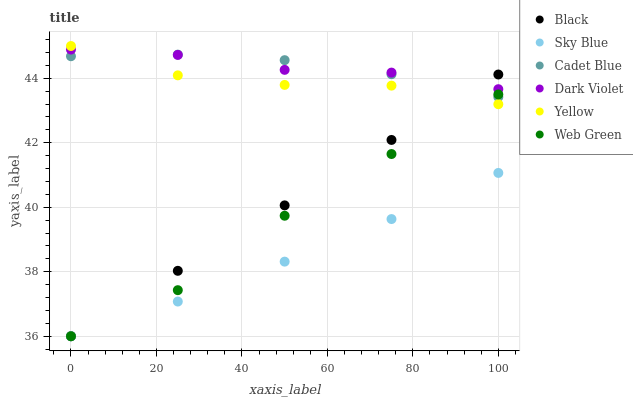Does Sky Blue have the minimum area under the curve?
Answer yes or no. Yes. Does Cadet Blue have the maximum area under the curve?
Answer yes or no. Yes. Does Dark Violet have the minimum area under the curve?
Answer yes or no. No. Does Dark Violet have the maximum area under the curve?
Answer yes or no. No. Is Black the smoothest?
Answer yes or no. Yes. Is Yellow the roughest?
Answer yes or no. Yes. Is Dark Violet the smoothest?
Answer yes or no. No. Is Dark Violet the roughest?
Answer yes or no. No. Does Web Green have the lowest value?
Answer yes or no. Yes. Does Dark Violet have the lowest value?
Answer yes or no. No. Does Yellow have the highest value?
Answer yes or no. Yes. Does Dark Violet have the highest value?
Answer yes or no. No. Is Web Green less than Dark Violet?
Answer yes or no. Yes. Is Yellow greater than Sky Blue?
Answer yes or no. Yes. Does Cadet Blue intersect Dark Violet?
Answer yes or no. Yes. Is Cadet Blue less than Dark Violet?
Answer yes or no. No. Is Cadet Blue greater than Dark Violet?
Answer yes or no. No. Does Web Green intersect Dark Violet?
Answer yes or no. No. 